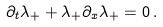Convert formula to latex. <formula><loc_0><loc_0><loc_500><loc_500>\partial _ { t } \lambda _ { + } + \lambda _ { + } \partial _ { x } \lambda _ { + } = 0 \, .</formula> 